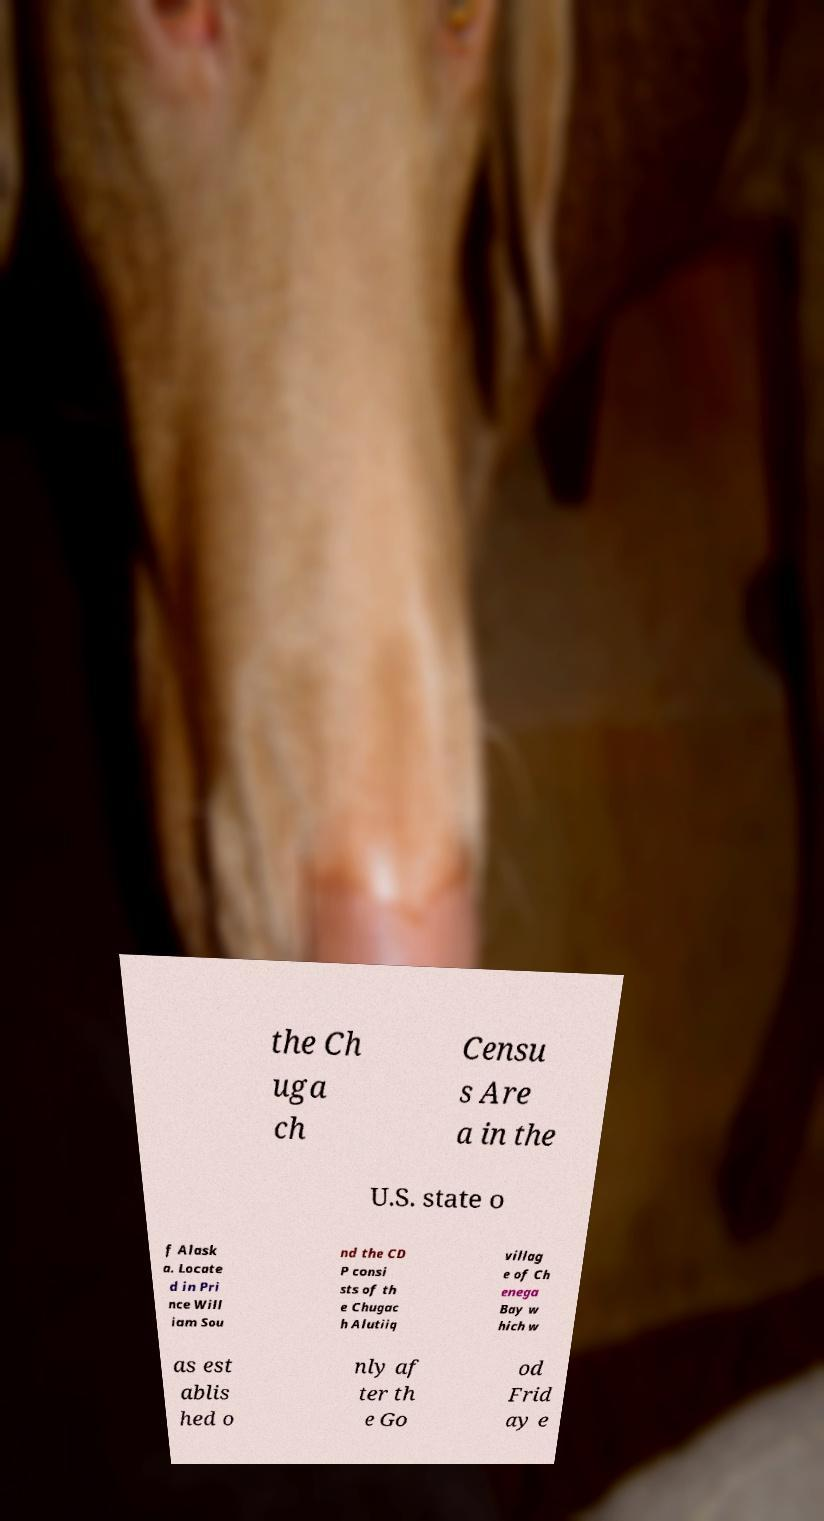Can you accurately transcribe the text from the provided image for me? the Ch uga ch Censu s Are a in the U.S. state o f Alask a. Locate d in Pri nce Will iam Sou nd the CD P consi sts of th e Chugac h Alutiiq villag e of Ch enega Bay w hich w as est ablis hed o nly af ter th e Go od Frid ay e 